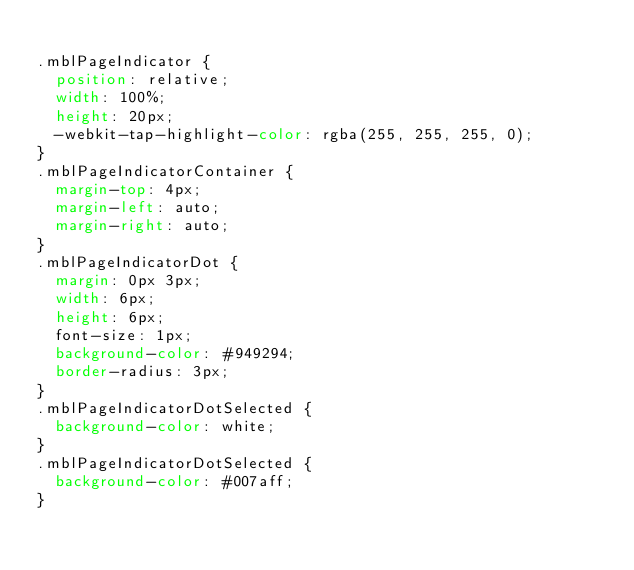<code> <loc_0><loc_0><loc_500><loc_500><_CSS_>
.mblPageIndicator {
  position: relative;
  width: 100%;
  height: 20px;
  -webkit-tap-highlight-color: rgba(255, 255, 255, 0);
}
.mblPageIndicatorContainer {
  margin-top: 4px;
  margin-left: auto;
  margin-right: auto;
}
.mblPageIndicatorDot {
  margin: 0px 3px;
  width: 6px;
  height: 6px;
  font-size: 1px;
  background-color: #949294;
  border-radius: 3px;
}
.mblPageIndicatorDotSelected {
  background-color: white;
}
.mblPageIndicatorDotSelected {
  background-color: #007aff;
}
</code> 